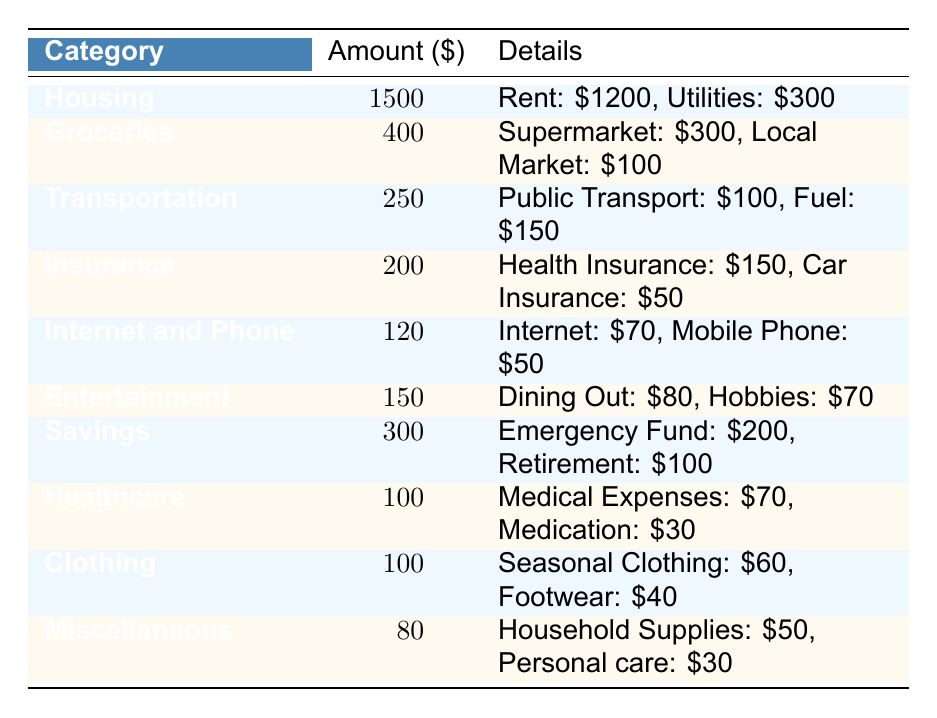What is the highest monthly expense category? The table shows all categories and their corresponding amounts. The highest amount listed is for Housing at 1500.
Answer: Housing How much is spent on Groceries? The table specifies that the total amount for Groceries is 400.
Answer: 400 What is the total amount spent on Transportation and Healthcare combined? Transportation is 250 and Healthcare is 100. Summing them gives 250 + 100 = 350.
Answer: 350 Is the amount spent on Internet and Phone greater than the amount spent on Clothing? The amount for Internet and Phone is 120, while Clothing is 100. Since 120 is greater than 100, the answer is yes.
Answer: Yes What percentage of the total monthly expenses is allocated to Savings? First, sum the total monthly expenses: 1500 + 400 + 250 + 200 + 120 + 150 + 300 + 100 + 100 + 80 = 3000. Then, calculate the percentage for Savings: (300 / 3000) * 100 = 10%.
Answer: 10% What is the difference in amount between Housing and Entertainment? The amount for Housing is 1500, and for Entertainment, it is 150. The difference is 1500 - 150 = 1350.
Answer: 1350 Which category has the lowest expense? Looking at the amounts, Miscellaneous has the lowest amount at 80.
Answer: Miscellaneous What is the total spent on Insurance, Healthcare, and Clothing? The amounts are: Insurance 200, Healthcare 100, and Clothing 100. Adding them gives 200 + 100 + 100 = 400.
Answer: 400 Is the amount spent on Dining Out more than the amount for Fuel? The amount for Dining Out is 80 and for Fuel is 150. Since 80 is less than 150, the answer is no.
Answer: No 